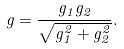Convert formula to latex. <formula><loc_0><loc_0><loc_500><loc_500>g = \frac { g _ { 1 } g _ { 2 } } { \sqrt { g _ { 1 } ^ { 2 } + g _ { 2 } ^ { 2 } } } .</formula> 